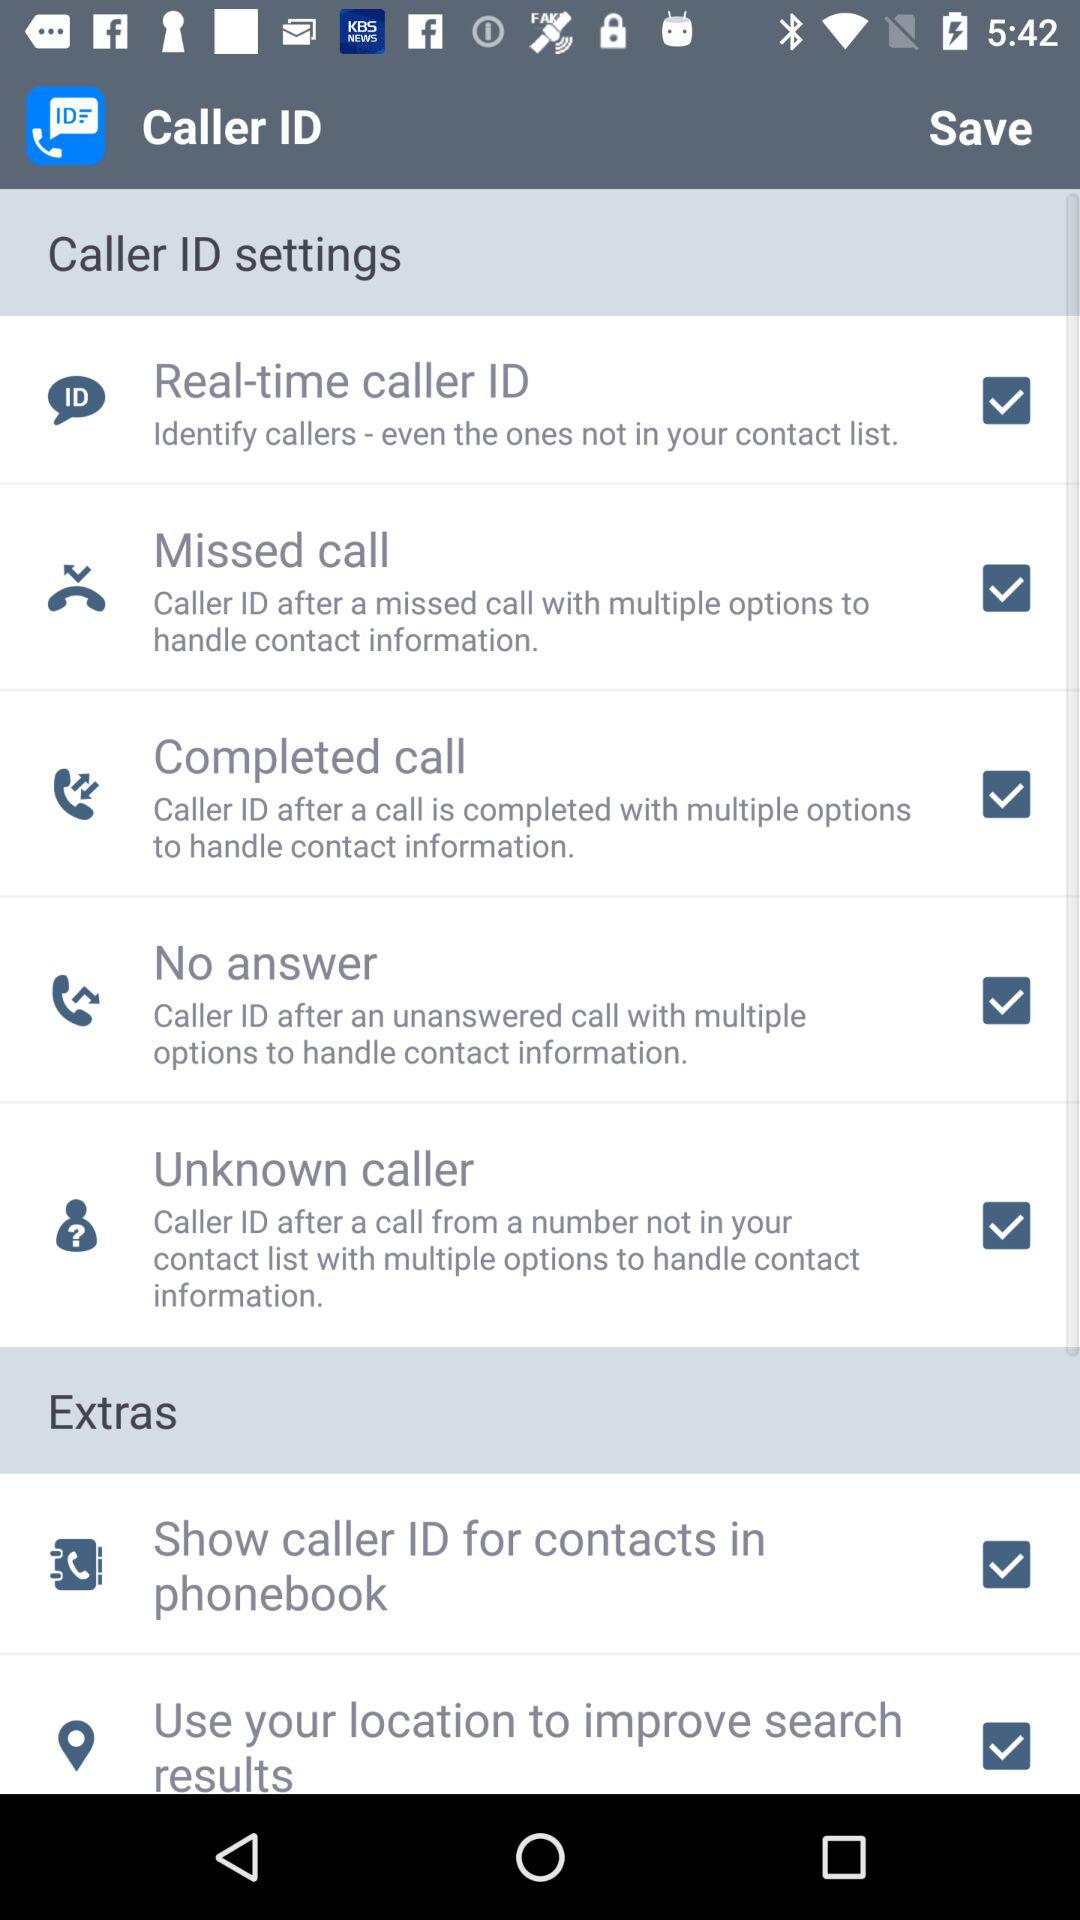What is the status of "Real-time caller ID" checkbox? The status is "on". 